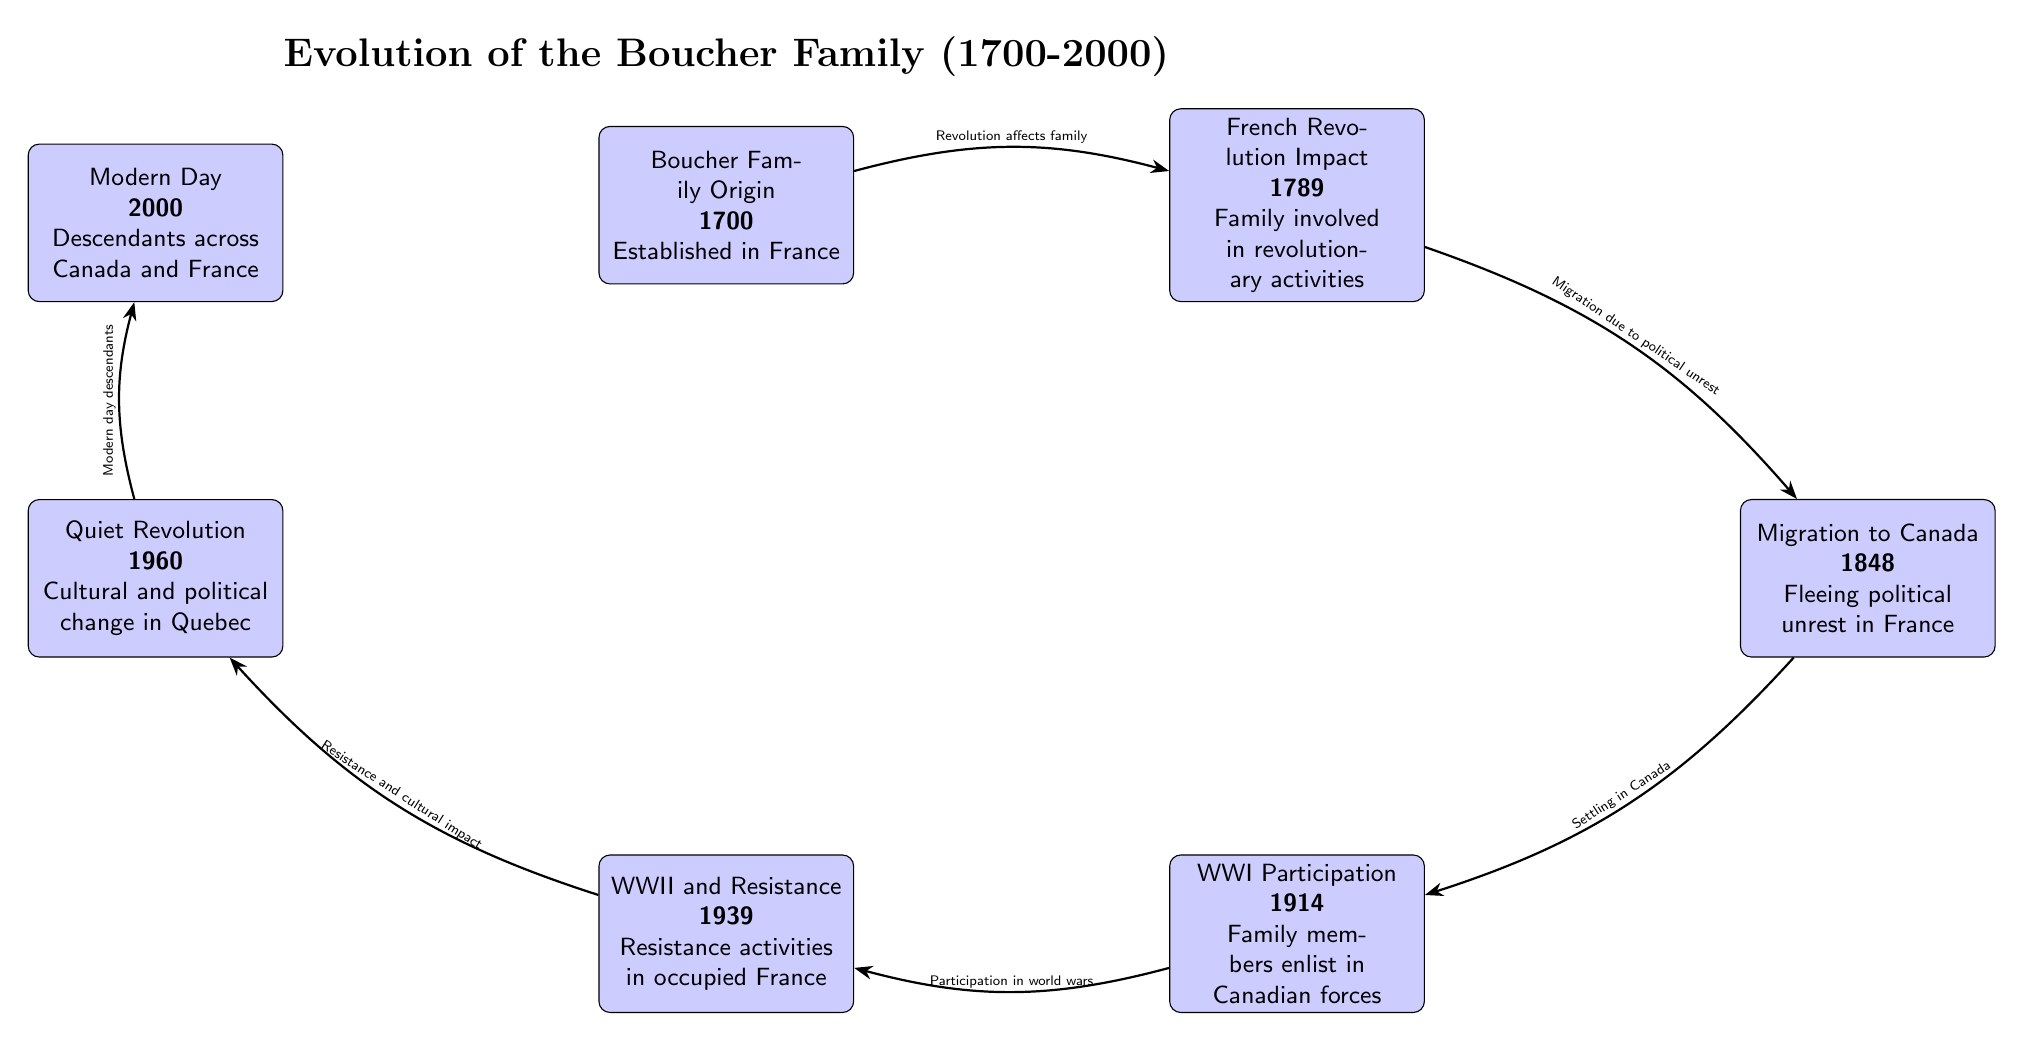What year marks the origin of the Boucher family? The diagram indicates that the Boucher family originated in the year 1700, as shown in the node labeled "Boucher Family Origin."
Answer: 1700 What significant event influenced the Boucher family in 1789? According to the diagram, the French Revolution is the significant event that impacted the Boucher family, as highlighted in the node for that year.
Answer: French Revolution How many major historical events are listed in the diagram? By counting the events detailed in the diagram, there are a total of six nodes/events, each representing a significant moment in the Boucher family's history.
Answer: 6 What event led to the Boucher family's migration in 1848? The diagram shows that the event leading to migration in 1848 was political unrest in France following the impacts of the French Revolution, as stated in the arrow labeling.
Answer: Political unrest Which event is connected to family participation in global conflict? The nodes for WWI Participation (1914) and WWII and Resistance (1939) indicate the family's involvement in world wars, illustrating a connection to global conflict.
Answer: World Wars What was the cultural change referred to in 1960? The diagram specifies that the event in 1960 was the "Quiet Revolution," which refers to cultural and political change in Quebec, as noted in the respective node.
Answer: Quiet Revolution How does the "Modern Day" node relate to the earlier events? The "Modern Day" node (2000) is connected to the developments from the "Quiet Revolution" (1960), indicating that the cultural and political changes led to a diverse descendant community in Canada and France.
Answer: Cultural impact What relationship exists between the events of 1789 and 1848? The diagram shows that the event in 1789 (French Revolution Impact) directly influenced the migration of the Boucher family in 1848, as indicated by the arrow labeling between these two nodes.
Answer: Migration due to political unrest What does the arrow labeled "Resistance and cultural impact" signify? This arrow indicates that the family's involvement in resistance activities during WWII (1939) had a lasting impact on their cultural identity, leading into the discussions of future changes expressed in the 1960 node.
Answer: Cultural impact 